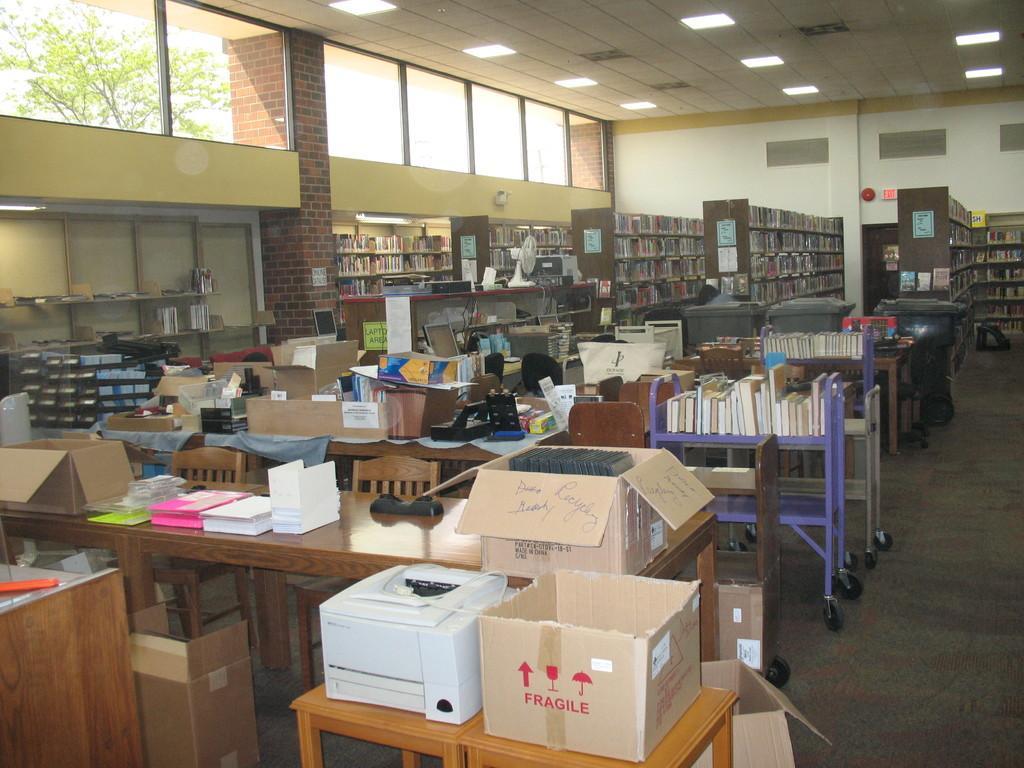Could you give a brief overview of what you see in this image? This is the picture of the place where we have a lot of things on the shelf and some things on the desk. 